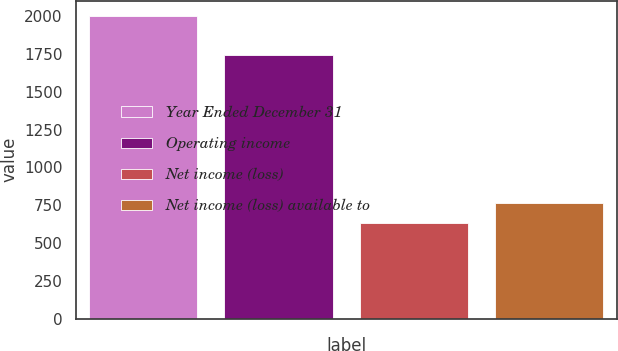<chart> <loc_0><loc_0><loc_500><loc_500><bar_chart><fcel>Year Ended December 31<fcel>Operating income<fcel>Net income (loss)<fcel>Net income (loss) available to<nl><fcel>2002<fcel>1744<fcel>630<fcel>767.2<nl></chart> 